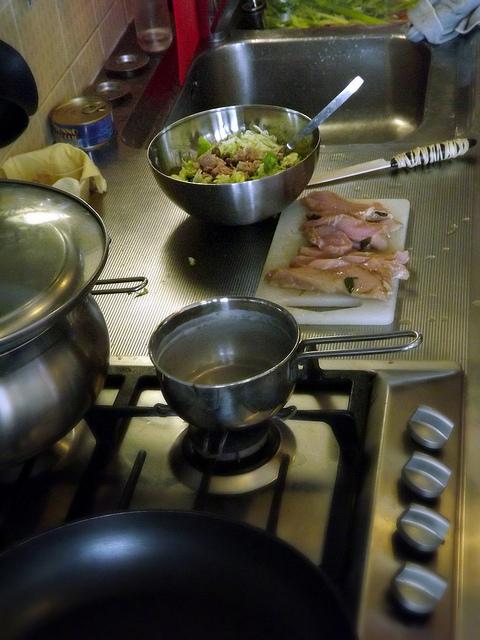What design is the knife by the cutting board?
Quick response, please. Zebra. How many pans are there?
Be succinct. 3. How many knobs are on the stove?
Give a very brief answer. 4. What is laying on the cutting board?
Keep it brief. Chicken. Do these look like antiques?
Answer briefly. No. What is being cooked?
Concise answer only. Chicken. Is the stove turned on?
Short answer required. No. What is the slotted object?
Keep it brief. Spoon. 